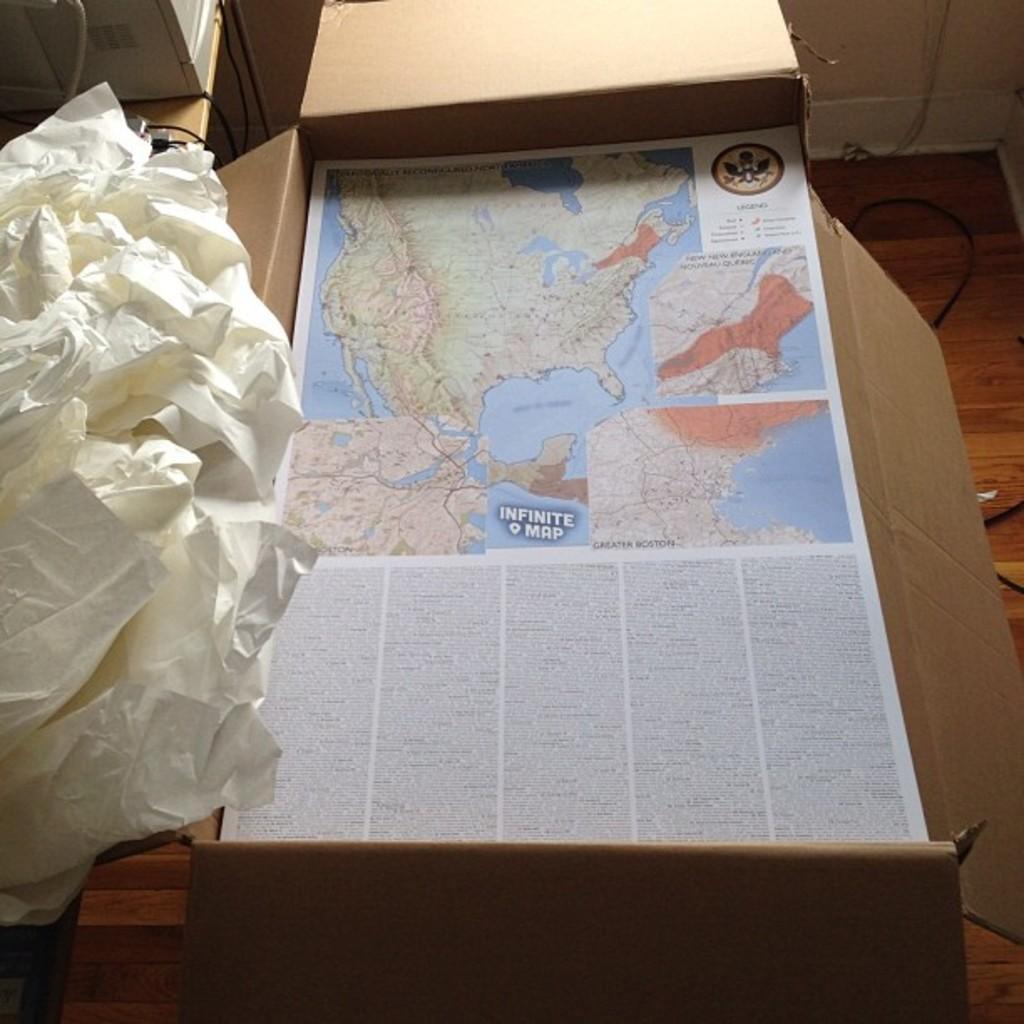Please provide a concise description of this image. In this image there is a cardboard box having a poster. On the poster there is an image of a map and some text. Left side there is a table having few papers and an object. Right top there is a wall. Background there is a floor. 